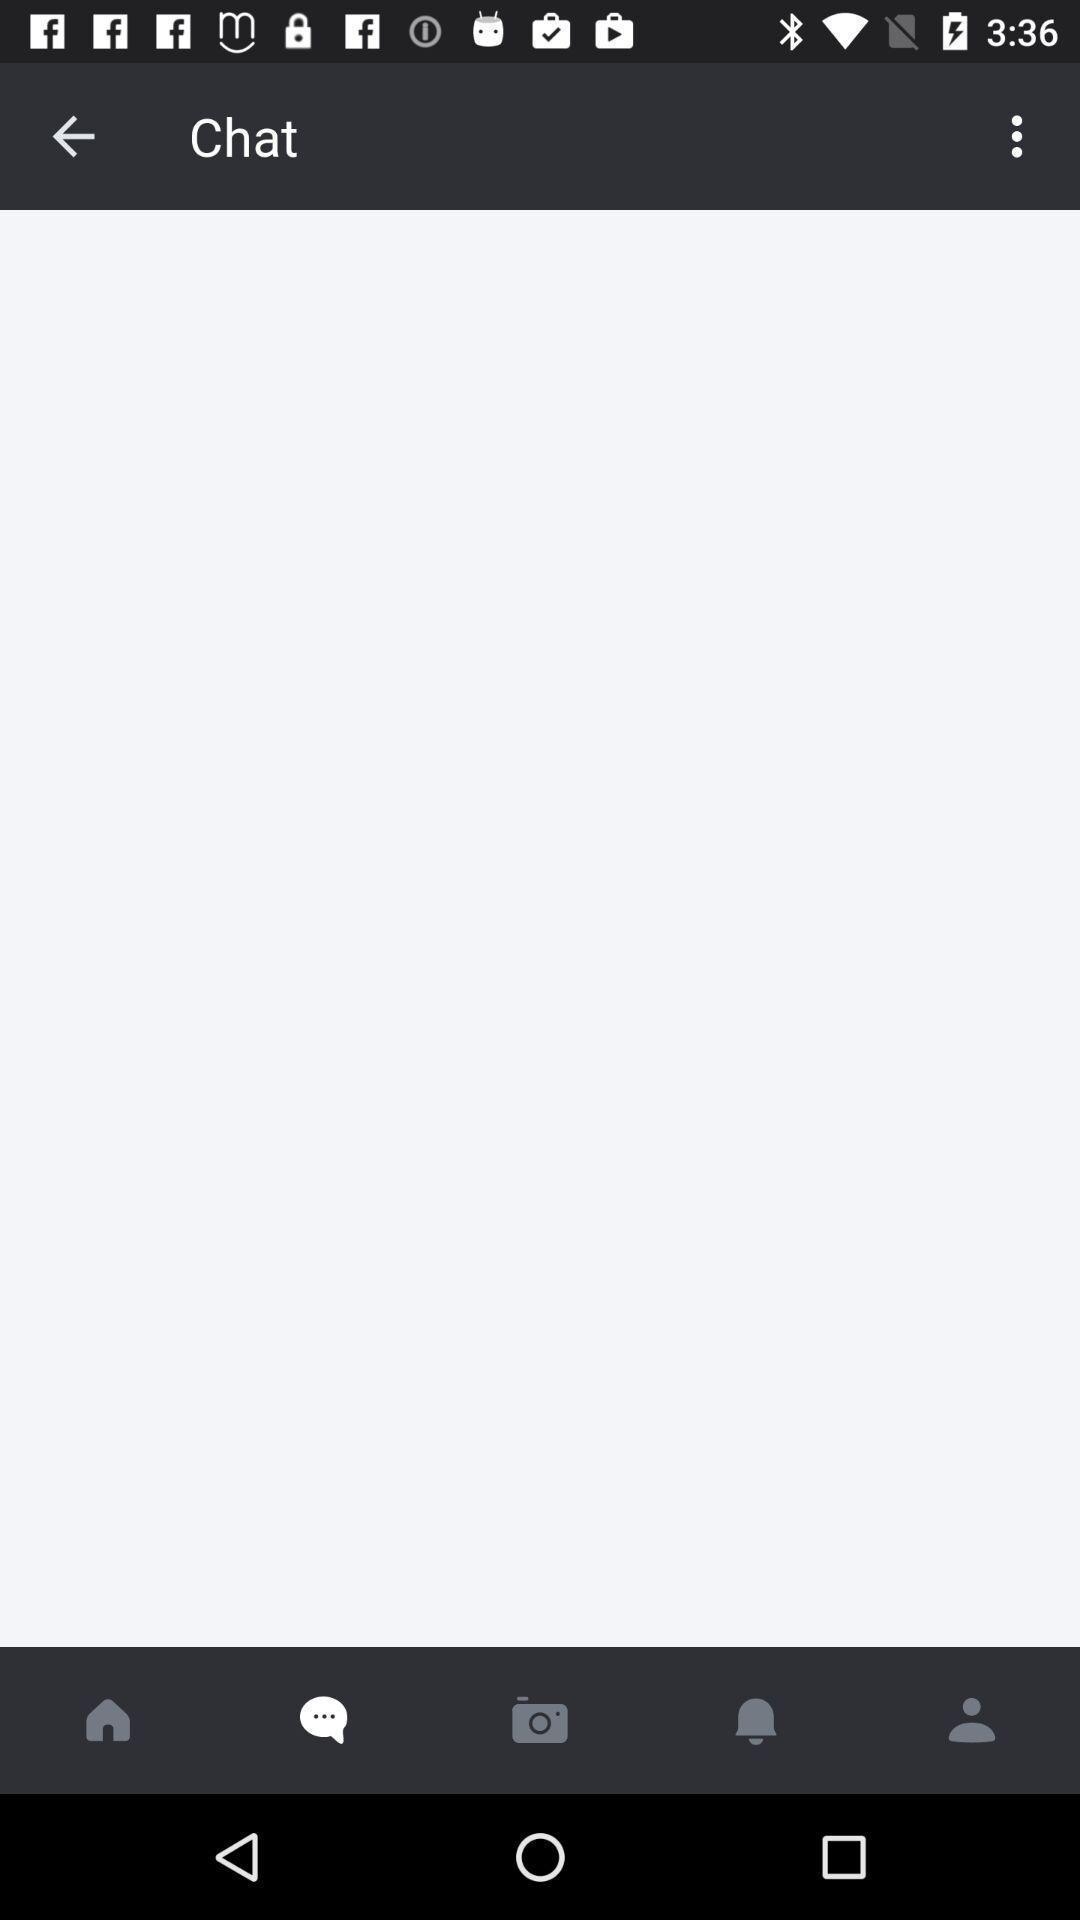Give me a narrative description of this picture. Page showing different options on a messaging app. 